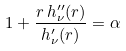Convert formula to latex. <formula><loc_0><loc_0><loc_500><loc_500>1 + \frac { r \, h _ { \nu } ^ { \prime \prime } ( r ) } { h _ { \nu } ^ { \prime } ( r ) } = \alpha</formula> 